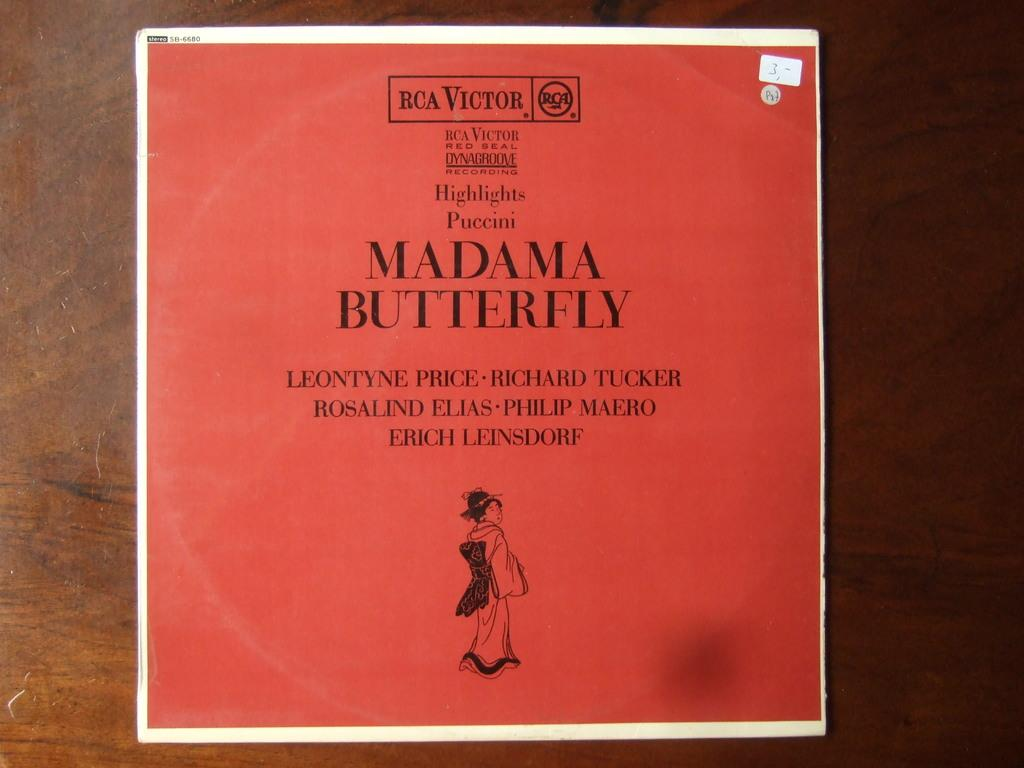<image>
Share a concise interpretation of the image provided. An orange red colored paper that is square and reads Madama Butterfly 